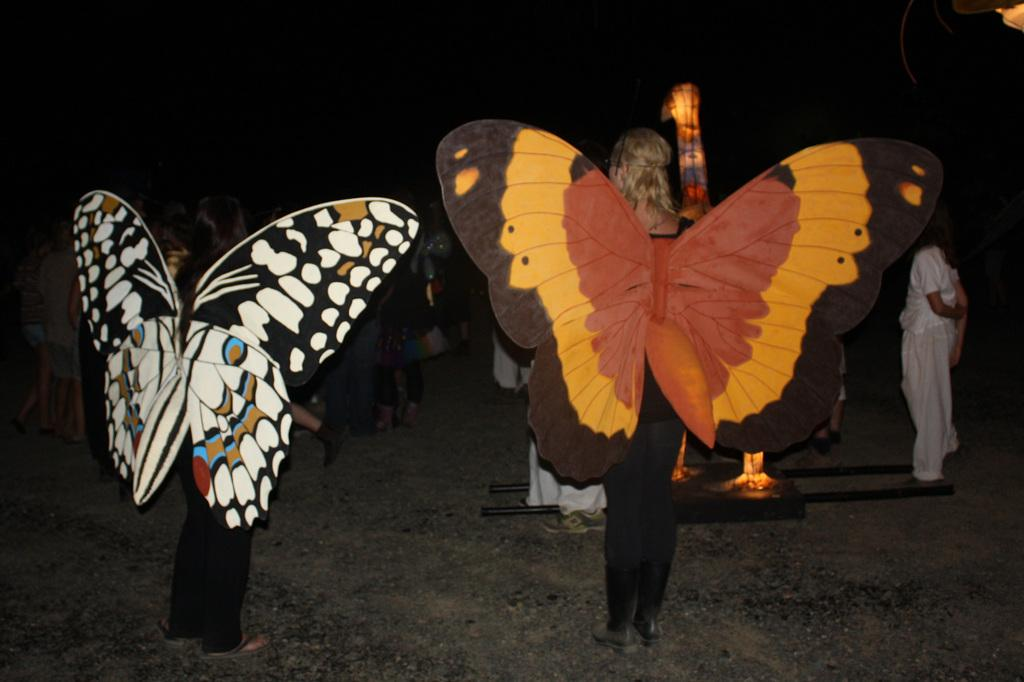How many people are in the image? There is a group of people in the image, but the exact number is not specified. What is the position of the people in the image? The people are standing on the ground in the image. What is unique about the attire of some of the people? Some of the people are wearing butterfly wings in the image. What type of curve can be seen on the earth in the image? There is no curve on the earth visible in the image, nor is there any reference to the earth in the provided facts. 